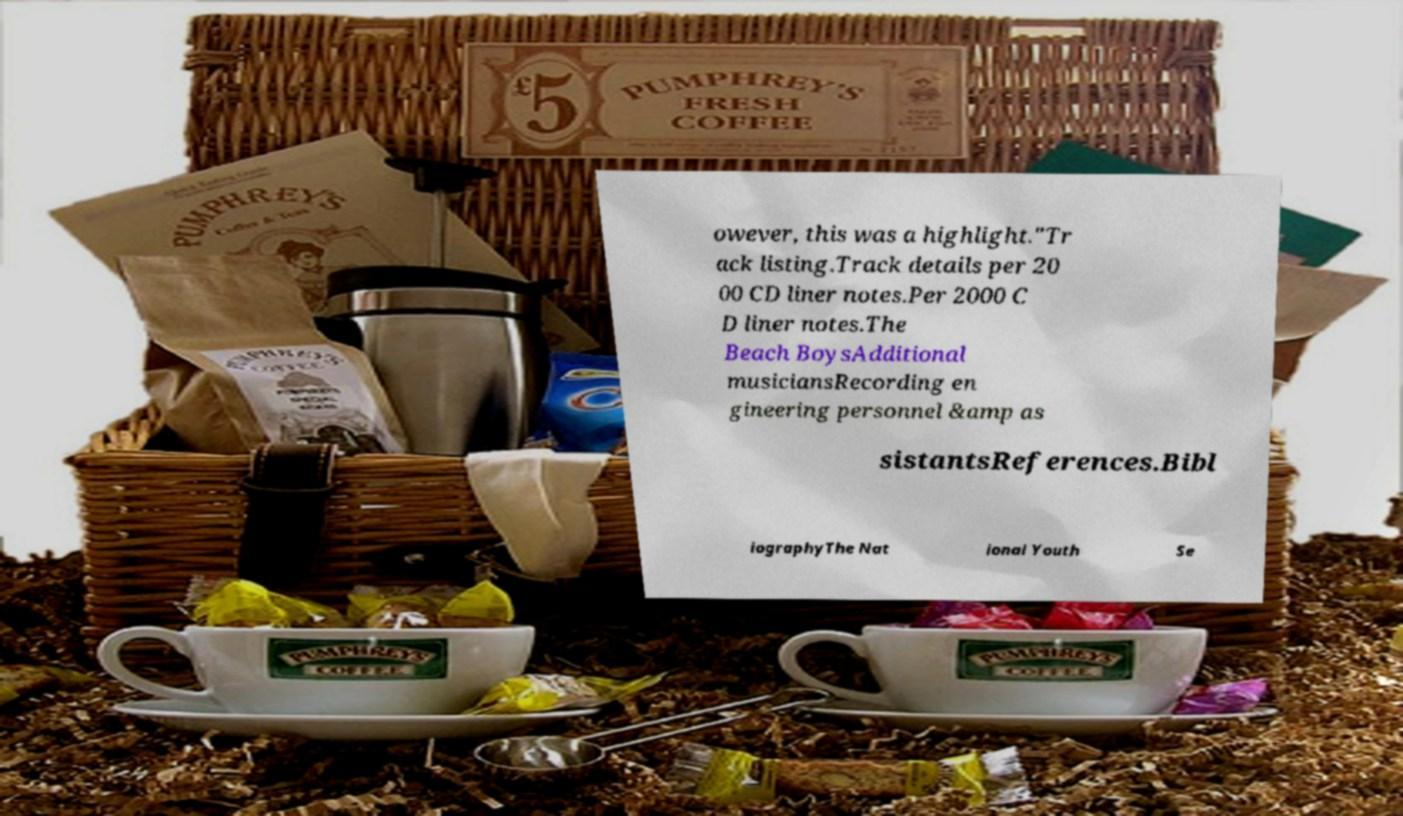What messages or text are displayed in this image? I need them in a readable, typed format. owever, this was a highlight."Tr ack listing.Track details per 20 00 CD liner notes.Per 2000 C D liner notes.The Beach BoysAdditional musiciansRecording en gineering personnel &amp as sistantsReferences.Bibl iographyThe Nat ional Youth Se 